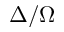Convert formula to latex. <formula><loc_0><loc_0><loc_500><loc_500>\Delta / \Omega</formula> 